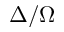Convert formula to latex. <formula><loc_0><loc_0><loc_500><loc_500>\Delta / \Omega</formula> 